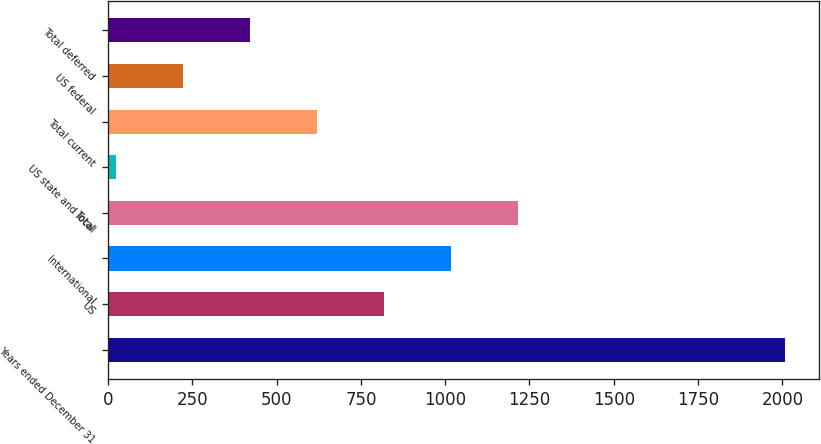Convert chart to OTSL. <chart><loc_0><loc_0><loc_500><loc_500><bar_chart><fcel>Years ended December 31<fcel>US<fcel>International<fcel>Total<fcel>US state and local<fcel>Total current<fcel>US federal<fcel>Total deferred<nl><fcel>2009<fcel>817.4<fcel>1016<fcel>1214.6<fcel>23<fcel>618.8<fcel>221.6<fcel>420.2<nl></chart> 